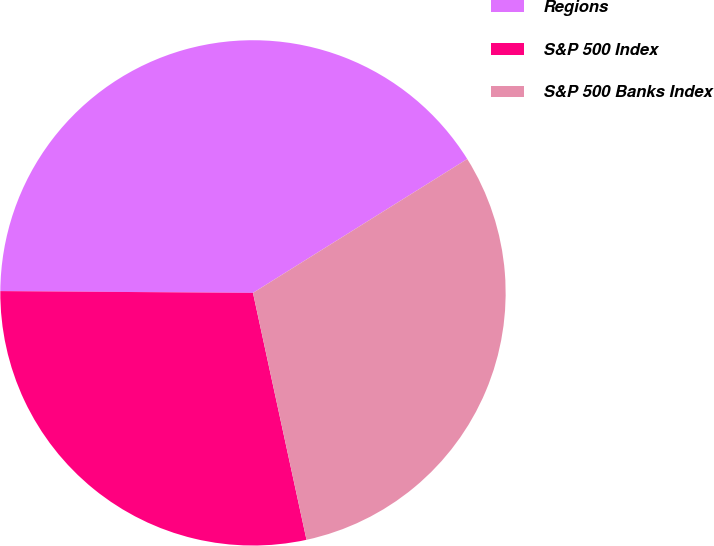Convert chart to OTSL. <chart><loc_0><loc_0><loc_500><loc_500><pie_chart><fcel>Regions<fcel>S&P 500 Index<fcel>S&P 500 Banks Index<nl><fcel>41.0%<fcel>28.51%<fcel>30.49%<nl></chart> 